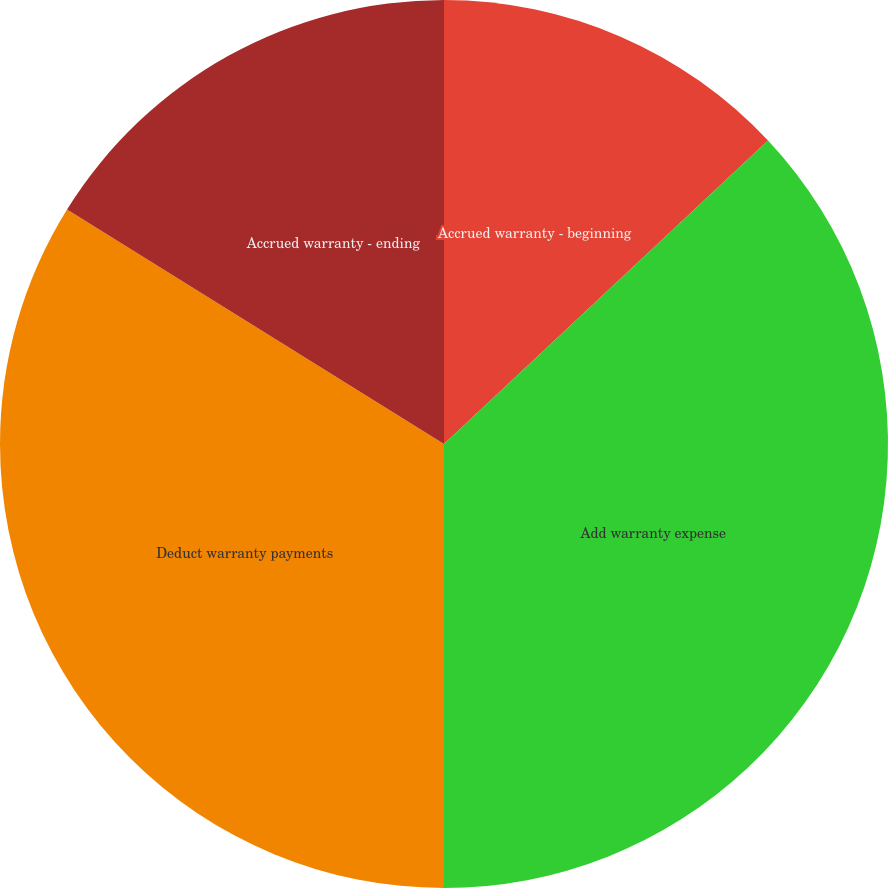Convert chart to OTSL. <chart><loc_0><loc_0><loc_500><loc_500><pie_chart><fcel>Accrued warranty - beginning<fcel>Add warranty expense<fcel>Deduct warranty payments<fcel>Accrued warranty - ending<nl><fcel>13.02%<fcel>36.98%<fcel>33.86%<fcel>16.14%<nl></chart> 